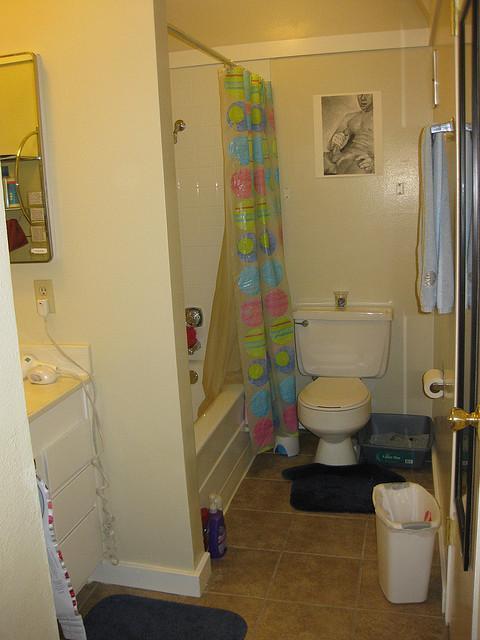How many plastic white forks can you count?
Give a very brief answer. 0. 